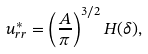<formula> <loc_0><loc_0><loc_500><loc_500>u ^ { * } _ { r r } = \left ( \frac { A } { \pi } \right ) ^ { 3 / 2 } H ( \delta ) ,</formula> 